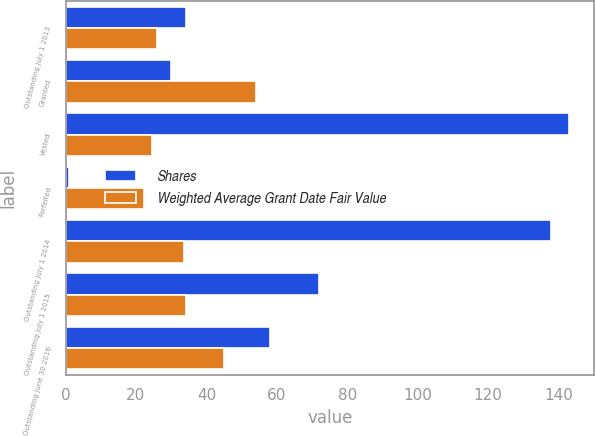<chart> <loc_0><loc_0><loc_500><loc_500><stacked_bar_chart><ecel><fcel>Outstanding July 1 2013<fcel>Granted<fcel>Vested<fcel>Forfeited<fcel>Outstanding July 1 2014<fcel>Outstanding July 1 2015<fcel>Outstanding June 30 2016<nl><fcel>Shares<fcel>34.28<fcel>30<fcel>143<fcel>1<fcel>138<fcel>72<fcel>58<nl><fcel>Weighted Average Grant Date Fair Value<fcel>25.92<fcel>54.13<fcel>24.41<fcel>22.17<fcel>33.56<fcel>34.28<fcel>44.95<nl></chart> 